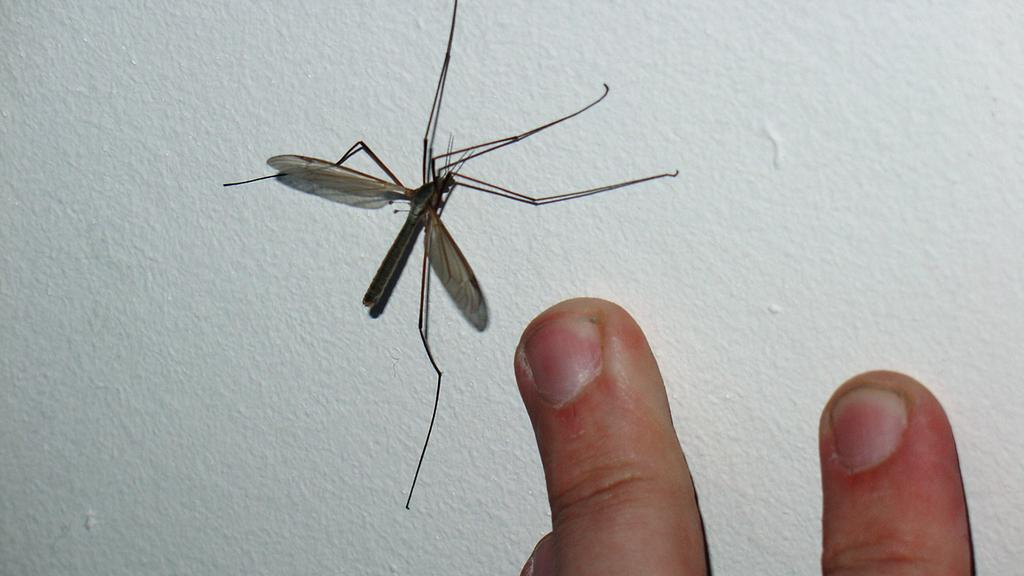What is the main subject in the center of the image? There is an insect in the center of the image. What else can be seen at the bottom of the image? There are fingers of a person at the bottom of the image. What type of spark can be seen coming from the insect in the image? There is no spark present in the image; it features an insect and fingers of a person. 